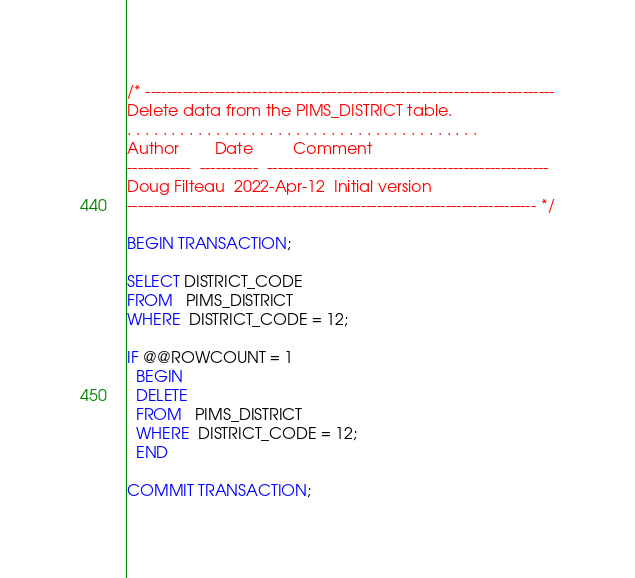<code> <loc_0><loc_0><loc_500><loc_500><_SQL_>/* -----------------------------------------------------------------------------
Delete data from the PIMS_DISTRICT table.
. . . . . . . . . . . . . . . . . . . . . . . . . . . . . . . . . . . . . . . . 
Author        Date         Comment
------------  -----------  -----------------------------------------------------
Doug Filteau  2022-Apr-12  Initial version
----------------------------------------------------------------------------- */

BEGIN TRANSACTION;

SELECT DISTRICT_CODE
FROM   PIMS_DISTRICT
WHERE  DISTRICT_CODE = 12;

IF @@ROWCOUNT = 1
  BEGIN
  DELETE
  FROM   PIMS_DISTRICT
  WHERE  DISTRICT_CODE = 12;
  END

COMMIT TRANSACTION;
</code> 